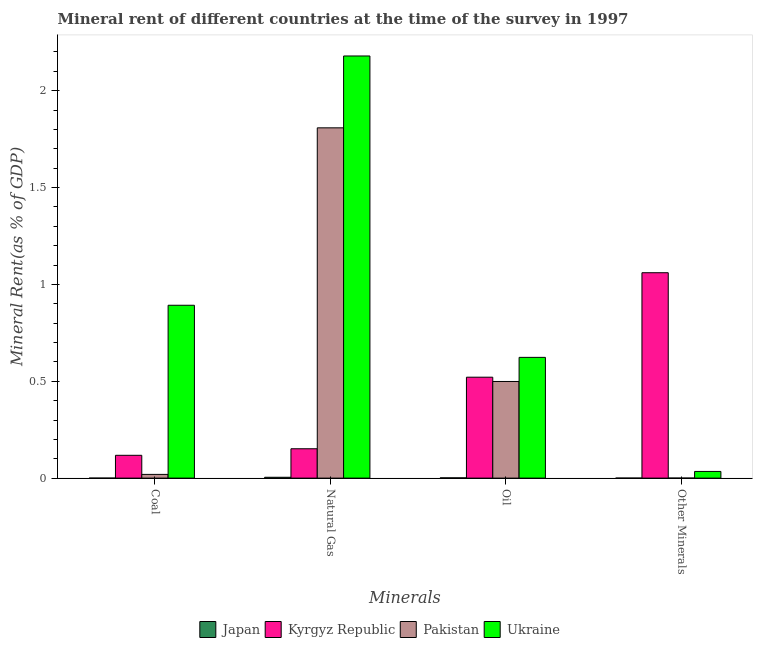Are the number of bars per tick equal to the number of legend labels?
Your response must be concise. Yes. Are the number of bars on each tick of the X-axis equal?
Provide a succinct answer. Yes. How many bars are there on the 3rd tick from the right?
Your answer should be compact. 4. What is the label of the 4th group of bars from the left?
Provide a short and direct response. Other Minerals. What is the natural gas rent in Pakistan?
Provide a succinct answer. 1.81. Across all countries, what is the maximum  rent of other minerals?
Provide a succinct answer. 1.06. Across all countries, what is the minimum oil rent?
Your answer should be compact. 0. In which country was the natural gas rent maximum?
Provide a succinct answer. Ukraine. In which country was the oil rent minimum?
Offer a terse response. Japan. What is the total  rent of other minerals in the graph?
Your answer should be compact. 1.1. What is the difference between the  rent of other minerals in Japan and that in Kyrgyz Republic?
Provide a short and direct response. -1.06. What is the difference between the  rent of other minerals in Japan and the coal rent in Ukraine?
Your answer should be compact. -0.89. What is the average  rent of other minerals per country?
Your answer should be very brief. 0.27. What is the difference between the oil rent and natural gas rent in Ukraine?
Ensure brevity in your answer.  -1.56. In how many countries, is the coal rent greater than 0.8 %?
Make the answer very short. 1. What is the ratio of the  rent of other minerals in Pakistan to that in Kyrgyz Republic?
Your answer should be compact. 0. Is the  rent of other minerals in Pakistan less than that in Kyrgyz Republic?
Ensure brevity in your answer.  Yes. What is the difference between the highest and the second highest oil rent?
Keep it short and to the point. 0.1. What is the difference between the highest and the lowest natural gas rent?
Offer a very short reply. 2.18. What does the 3rd bar from the left in Other Minerals represents?
Offer a terse response. Pakistan. What does the 3rd bar from the right in Coal represents?
Provide a succinct answer. Kyrgyz Republic. How many bars are there?
Provide a short and direct response. 16. Are all the bars in the graph horizontal?
Keep it short and to the point. No. How many countries are there in the graph?
Make the answer very short. 4. Are the values on the major ticks of Y-axis written in scientific E-notation?
Make the answer very short. No. How many legend labels are there?
Offer a very short reply. 4. What is the title of the graph?
Give a very brief answer. Mineral rent of different countries at the time of the survey in 1997. Does "Kenya" appear as one of the legend labels in the graph?
Keep it short and to the point. No. What is the label or title of the X-axis?
Offer a terse response. Minerals. What is the label or title of the Y-axis?
Keep it short and to the point. Mineral Rent(as % of GDP). What is the Mineral Rent(as % of GDP) of Japan in Coal?
Ensure brevity in your answer.  3.73329215235604e-7. What is the Mineral Rent(as % of GDP) in Kyrgyz Republic in Coal?
Keep it short and to the point. 0.12. What is the Mineral Rent(as % of GDP) in Pakistan in Coal?
Offer a terse response. 0.02. What is the Mineral Rent(as % of GDP) of Ukraine in Coal?
Offer a terse response. 0.89. What is the Mineral Rent(as % of GDP) in Japan in Natural Gas?
Provide a succinct answer. 0. What is the Mineral Rent(as % of GDP) in Kyrgyz Republic in Natural Gas?
Offer a terse response. 0.15. What is the Mineral Rent(as % of GDP) in Pakistan in Natural Gas?
Offer a very short reply. 1.81. What is the Mineral Rent(as % of GDP) of Ukraine in Natural Gas?
Your answer should be very brief. 2.18. What is the Mineral Rent(as % of GDP) in Japan in Oil?
Make the answer very short. 0. What is the Mineral Rent(as % of GDP) of Kyrgyz Republic in Oil?
Your answer should be very brief. 0.52. What is the Mineral Rent(as % of GDP) in Pakistan in Oil?
Give a very brief answer. 0.5. What is the Mineral Rent(as % of GDP) in Ukraine in Oil?
Give a very brief answer. 0.62. What is the Mineral Rent(as % of GDP) of Japan in Other Minerals?
Your answer should be compact. 4.86493891704915e-5. What is the Mineral Rent(as % of GDP) of Kyrgyz Republic in Other Minerals?
Your answer should be compact. 1.06. What is the Mineral Rent(as % of GDP) of Pakistan in Other Minerals?
Provide a short and direct response. 0. What is the Mineral Rent(as % of GDP) in Ukraine in Other Minerals?
Offer a terse response. 0.03. Across all Minerals, what is the maximum Mineral Rent(as % of GDP) in Japan?
Ensure brevity in your answer.  0. Across all Minerals, what is the maximum Mineral Rent(as % of GDP) of Kyrgyz Republic?
Provide a succinct answer. 1.06. Across all Minerals, what is the maximum Mineral Rent(as % of GDP) of Pakistan?
Offer a terse response. 1.81. Across all Minerals, what is the maximum Mineral Rent(as % of GDP) of Ukraine?
Your answer should be compact. 2.18. Across all Minerals, what is the minimum Mineral Rent(as % of GDP) in Japan?
Your answer should be very brief. 3.73329215235604e-7. Across all Minerals, what is the minimum Mineral Rent(as % of GDP) of Kyrgyz Republic?
Your answer should be compact. 0.12. Across all Minerals, what is the minimum Mineral Rent(as % of GDP) of Pakistan?
Offer a terse response. 0. Across all Minerals, what is the minimum Mineral Rent(as % of GDP) of Ukraine?
Give a very brief answer. 0.03. What is the total Mineral Rent(as % of GDP) of Japan in the graph?
Make the answer very short. 0.01. What is the total Mineral Rent(as % of GDP) in Kyrgyz Republic in the graph?
Give a very brief answer. 1.85. What is the total Mineral Rent(as % of GDP) of Pakistan in the graph?
Offer a terse response. 2.33. What is the total Mineral Rent(as % of GDP) of Ukraine in the graph?
Make the answer very short. 3.73. What is the difference between the Mineral Rent(as % of GDP) in Japan in Coal and that in Natural Gas?
Offer a terse response. -0. What is the difference between the Mineral Rent(as % of GDP) in Kyrgyz Republic in Coal and that in Natural Gas?
Make the answer very short. -0.03. What is the difference between the Mineral Rent(as % of GDP) in Pakistan in Coal and that in Natural Gas?
Offer a very short reply. -1.79. What is the difference between the Mineral Rent(as % of GDP) in Ukraine in Coal and that in Natural Gas?
Your answer should be compact. -1.29. What is the difference between the Mineral Rent(as % of GDP) of Japan in Coal and that in Oil?
Offer a terse response. -0. What is the difference between the Mineral Rent(as % of GDP) of Kyrgyz Republic in Coal and that in Oil?
Provide a succinct answer. -0.4. What is the difference between the Mineral Rent(as % of GDP) of Pakistan in Coal and that in Oil?
Keep it short and to the point. -0.48. What is the difference between the Mineral Rent(as % of GDP) of Ukraine in Coal and that in Oil?
Your answer should be very brief. 0.27. What is the difference between the Mineral Rent(as % of GDP) of Japan in Coal and that in Other Minerals?
Provide a succinct answer. -0. What is the difference between the Mineral Rent(as % of GDP) in Kyrgyz Republic in Coal and that in Other Minerals?
Make the answer very short. -0.94. What is the difference between the Mineral Rent(as % of GDP) in Pakistan in Coal and that in Other Minerals?
Make the answer very short. 0.02. What is the difference between the Mineral Rent(as % of GDP) in Ukraine in Coal and that in Other Minerals?
Your response must be concise. 0.86. What is the difference between the Mineral Rent(as % of GDP) of Japan in Natural Gas and that in Oil?
Your answer should be compact. 0. What is the difference between the Mineral Rent(as % of GDP) of Kyrgyz Republic in Natural Gas and that in Oil?
Provide a short and direct response. -0.37. What is the difference between the Mineral Rent(as % of GDP) in Pakistan in Natural Gas and that in Oil?
Provide a succinct answer. 1.31. What is the difference between the Mineral Rent(as % of GDP) in Ukraine in Natural Gas and that in Oil?
Provide a succinct answer. 1.56. What is the difference between the Mineral Rent(as % of GDP) in Japan in Natural Gas and that in Other Minerals?
Your response must be concise. 0. What is the difference between the Mineral Rent(as % of GDP) of Kyrgyz Republic in Natural Gas and that in Other Minerals?
Your answer should be compact. -0.91. What is the difference between the Mineral Rent(as % of GDP) in Pakistan in Natural Gas and that in Other Minerals?
Offer a very short reply. 1.81. What is the difference between the Mineral Rent(as % of GDP) of Ukraine in Natural Gas and that in Other Minerals?
Offer a terse response. 2.15. What is the difference between the Mineral Rent(as % of GDP) in Japan in Oil and that in Other Minerals?
Your answer should be very brief. 0. What is the difference between the Mineral Rent(as % of GDP) of Kyrgyz Republic in Oil and that in Other Minerals?
Give a very brief answer. -0.54. What is the difference between the Mineral Rent(as % of GDP) in Pakistan in Oil and that in Other Minerals?
Your answer should be very brief. 0.5. What is the difference between the Mineral Rent(as % of GDP) of Ukraine in Oil and that in Other Minerals?
Give a very brief answer. 0.59. What is the difference between the Mineral Rent(as % of GDP) in Japan in Coal and the Mineral Rent(as % of GDP) in Kyrgyz Republic in Natural Gas?
Offer a very short reply. -0.15. What is the difference between the Mineral Rent(as % of GDP) in Japan in Coal and the Mineral Rent(as % of GDP) in Pakistan in Natural Gas?
Give a very brief answer. -1.81. What is the difference between the Mineral Rent(as % of GDP) in Japan in Coal and the Mineral Rent(as % of GDP) in Ukraine in Natural Gas?
Your answer should be very brief. -2.18. What is the difference between the Mineral Rent(as % of GDP) of Kyrgyz Republic in Coal and the Mineral Rent(as % of GDP) of Pakistan in Natural Gas?
Give a very brief answer. -1.69. What is the difference between the Mineral Rent(as % of GDP) in Kyrgyz Republic in Coal and the Mineral Rent(as % of GDP) in Ukraine in Natural Gas?
Provide a succinct answer. -2.06. What is the difference between the Mineral Rent(as % of GDP) of Pakistan in Coal and the Mineral Rent(as % of GDP) of Ukraine in Natural Gas?
Your answer should be compact. -2.16. What is the difference between the Mineral Rent(as % of GDP) in Japan in Coal and the Mineral Rent(as % of GDP) in Kyrgyz Republic in Oil?
Ensure brevity in your answer.  -0.52. What is the difference between the Mineral Rent(as % of GDP) of Japan in Coal and the Mineral Rent(as % of GDP) of Pakistan in Oil?
Your response must be concise. -0.5. What is the difference between the Mineral Rent(as % of GDP) in Japan in Coal and the Mineral Rent(as % of GDP) in Ukraine in Oil?
Give a very brief answer. -0.62. What is the difference between the Mineral Rent(as % of GDP) of Kyrgyz Republic in Coal and the Mineral Rent(as % of GDP) of Pakistan in Oil?
Your answer should be very brief. -0.38. What is the difference between the Mineral Rent(as % of GDP) of Kyrgyz Republic in Coal and the Mineral Rent(as % of GDP) of Ukraine in Oil?
Offer a very short reply. -0.51. What is the difference between the Mineral Rent(as % of GDP) in Pakistan in Coal and the Mineral Rent(as % of GDP) in Ukraine in Oil?
Give a very brief answer. -0.6. What is the difference between the Mineral Rent(as % of GDP) of Japan in Coal and the Mineral Rent(as % of GDP) of Kyrgyz Republic in Other Minerals?
Offer a very short reply. -1.06. What is the difference between the Mineral Rent(as % of GDP) in Japan in Coal and the Mineral Rent(as % of GDP) in Pakistan in Other Minerals?
Your answer should be very brief. -0. What is the difference between the Mineral Rent(as % of GDP) in Japan in Coal and the Mineral Rent(as % of GDP) in Ukraine in Other Minerals?
Your response must be concise. -0.03. What is the difference between the Mineral Rent(as % of GDP) in Kyrgyz Republic in Coal and the Mineral Rent(as % of GDP) in Pakistan in Other Minerals?
Ensure brevity in your answer.  0.12. What is the difference between the Mineral Rent(as % of GDP) in Kyrgyz Republic in Coal and the Mineral Rent(as % of GDP) in Ukraine in Other Minerals?
Provide a short and direct response. 0.08. What is the difference between the Mineral Rent(as % of GDP) of Pakistan in Coal and the Mineral Rent(as % of GDP) of Ukraine in Other Minerals?
Your answer should be very brief. -0.02. What is the difference between the Mineral Rent(as % of GDP) of Japan in Natural Gas and the Mineral Rent(as % of GDP) of Kyrgyz Republic in Oil?
Your response must be concise. -0.52. What is the difference between the Mineral Rent(as % of GDP) in Japan in Natural Gas and the Mineral Rent(as % of GDP) in Pakistan in Oil?
Offer a terse response. -0.49. What is the difference between the Mineral Rent(as % of GDP) of Japan in Natural Gas and the Mineral Rent(as % of GDP) of Ukraine in Oil?
Keep it short and to the point. -0.62. What is the difference between the Mineral Rent(as % of GDP) in Kyrgyz Republic in Natural Gas and the Mineral Rent(as % of GDP) in Pakistan in Oil?
Give a very brief answer. -0.35. What is the difference between the Mineral Rent(as % of GDP) in Kyrgyz Republic in Natural Gas and the Mineral Rent(as % of GDP) in Ukraine in Oil?
Provide a succinct answer. -0.47. What is the difference between the Mineral Rent(as % of GDP) of Pakistan in Natural Gas and the Mineral Rent(as % of GDP) of Ukraine in Oil?
Your answer should be very brief. 1.19. What is the difference between the Mineral Rent(as % of GDP) of Japan in Natural Gas and the Mineral Rent(as % of GDP) of Kyrgyz Republic in Other Minerals?
Provide a succinct answer. -1.06. What is the difference between the Mineral Rent(as % of GDP) of Japan in Natural Gas and the Mineral Rent(as % of GDP) of Pakistan in Other Minerals?
Your answer should be very brief. 0. What is the difference between the Mineral Rent(as % of GDP) in Japan in Natural Gas and the Mineral Rent(as % of GDP) in Ukraine in Other Minerals?
Your response must be concise. -0.03. What is the difference between the Mineral Rent(as % of GDP) in Kyrgyz Republic in Natural Gas and the Mineral Rent(as % of GDP) in Pakistan in Other Minerals?
Ensure brevity in your answer.  0.15. What is the difference between the Mineral Rent(as % of GDP) in Kyrgyz Republic in Natural Gas and the Mineral Rent(as % of GDP) in Ukraine in Other Minerals?
Keep it short and to the point. 0.12. What is the difference between the Mineral Rent(as % of GDP) of Pakistan in Natural Gas and the Mineral Rent(as % of GDP) of Ukraine in Other Minerals?
Provide a succinct answer. 1.77. What is the difference between the Mineral Rent(as % of GDP) of Japan in Oil and the Mineral Rent(as % of GDP) of Kyrgyz Republic in Other Minerals?
Your answer should be very brief. -1.06. What is the difference between the Mineral Rent(as % of GDP) in Japan in Oil and the Mineral Rent(as % of GDP) in Pakistan in Other Minerals?
Your response must be concise. 0. What is the difference between the Mineral Rent(as % of GDP) in Japan in Oil and the Mineral Rent(as % of GDP) in Ukraine in Other Minerals?
Make the answer very short. -0.03. What is the difference between the Mineral Rent(as % of GDP) in Kyrgyz Republic in Oil and the Mineral Rent(as % of GDP) in Pakistan in Other Minerals?
Your answer should be compact. 0.52. What is the difference between the Mineral Rent(as % of GDP) of Kyrgyz Republic in Oil and the Mineral Rent(as % of GDP) of Ukraine in Other Minerals?
Keep it short and to the point. 0.49. What is the difference between the Mineral Rent(as % of GDP) in Pakistan in Oil and the Mineral Rent(as % of GDP) in Ukraine in Other Minerals?
Make the answer very short. 0.46. What is the average Mineral Rent(as % of GDP) in Japan per Minerals?
Your answer should be compact. 0. What is the average Mineral Rent(as % of GDP) of Kyrgyz Republic per Minerals?
Your answer should be compact. 0.46. What is the average Mineral Rent(as % of GDP) in Pakistan per Minerals?
Offer a very short reply. 0.58. What is the average Mineral Rent(as % of GDP) in Ukraine per Minerals?
Your response must be concise. 0.93. What is the difference between the Mineral Rent(as % of GDP) in Japan and Mineral Rent(as % of GDP) in Kyrgyz Republic in Coal?
Provide a succinct answer. -0.12. What is the difference between the Mineral Rent(as % of GDP) in Japan and Mineral Rent(as % of GDP) in Pakistan in Coal?
Your response must be concise. -0.02. What is the difference between the Mineral Rent(as % of GDP) of Japan and Mineral Rent(as % of GDP) of Ukraine in Coal?
Give a very brief answer. -0.89. What is the difference between the Mineral Rent(as % of GDP) of Kyrgyz Republic and Mineral Rent(as % of GDP) of Pakistan in Coal?
Offer a terse response. 0.1. What is the difference between the Mineral Rent(as % of GDP) in Kyrgyz Republic and Mineral Rent(as % of GDP) in Ukraine in Coal?
Your response must be concise. -0.77. What is the difference between the Mineral Rent(as % of GDP) in Pakistan and Mineral Rent(as % of GDP) in Ukraine in Coal?
Your response must be concise. -0.87. What is the difference between the Mineral Rent(as % of GDP) of Japan and Mineral Rent(as % of GDP) of Kyrgyz Republic in Natural Gas?
Give a very brief answer. -0.15. What is the difference between the Mineral Rent(as % of GDP) in Japan and Mineral Rent(as % of GDP) in Pakistan in Natural Gas?
Provide a succinct answer. -1.8. What is the difference between the Mineral Rent(as % of GDP) in Japan and Mineral Rent(as % of GDP) in Ukraine in Natural Gas?
Offer a very short reply. -2.17. What is the difference between the Mineral Rent(as % of GDP) in Kyrgyz Republic and Mineral Rent(as % of GDP) in Pakistan in Natural Gas?
Offer a very short reply. -1.66. What is the difference between the Mineral Rent(as % of GDP) in Kyrgyz Republic and Mineral Rent(as % of GDP) in Ukraine in Natural Gas?
Provide a succinct answer. -2.03. What is the difference between the Mineral Rent(as % of GDP) in Pakistan and Mineral Rent(as % of GDP) in Ukraine in Natural Gas?
Keep it short and to the point. -0.37. What is the difference between the Mineral Rent(as % of GDP) of Japan and Mineral Rent(as % of GDP) of Kyrgyz Republic in Oil?
Offer a terse response. -0.52. What is the difference between the Mineral Rent(as % of GDP) in Japan and Mineral Rent(as % of GDP) in Pakistan in Oil?
Provide a succinct answer. -0.5. What is the difference between the Mineral Rent(as % of GDP) in Japan and Mineral Rent(as % of GDP) in Ukraine in Oil?
Keep it short and to the point. -0.62. What is the difference between the Mineral Rent(as % of GDP) of Kyrgyz Republic and Mineral Rent(as % of GDP) of Pakistan in Oil?
Your answer should be very brief. 0.02. What is the difference between the Mineral Rent(as % of GDP) of Kyrgyz Republic and Mineral Rent(as % of GDP) of Ukraine in Oil?
Ensure brevity in your answer.  -0.1. What is the difference between the Mineral Rent(as % of GDP) of Pakistan and Mineral Rent(as % of GDP) of Ukraine in Oil?
Provide a succinct answer. -0.12. What is the difference between the Mineral Rent(as % of GDP) of Japan and Mineral Rent(as % of GDP) of Kyrgyz Republic in Other Minerals?
Provide a succinct answer. -1.06. What is the difference between the Mineral Rent(as % of GDP) in Japan and Mineral Rent(as % of GDP) in Pakistan in Other Minerals?
Provide a succinct answer. -0. What is the difference between the Mineral Rent(as % of GDP) of Japan and Mineral Rent(as % of GDP) of Ukraine in Other Minerals?
Give a very brief answer. -0.03. What is the difference between the Mineral Rent(as % of GDP) in Kyrgyz Republic and Mineral Rent(as % of GDP) in Pakistan in Other Minerals?
Ensure brevity in your answer.  1.06. What is the difference between the Mineral Rent(as % of GDP) of Kyrgyz Republic and Mineral Rent(as % of GDP) of Ukraine in Other Minerals?
Offer a very short reply. 1.03. What is the difference between the Mineral Rent(as % of GDP) of Pakistan and Mineral Rent(as % of GDP) of Ukraine in Other Minerals?
Offer a very short reply. -0.03. What is the ratio of the Mineral Rent(as % of GDP) in Kyrgyz Republic in Coal to that in Natural Gas?
Provide a short and direct response. 0.78. What is the ratio of the Mineral Rent(as % of GDP) of Pakistan in Coal to that in Natural Gas?
Your answer should be compact. 0.01. What is the ratio of the Mineral Rent(as % of GDP) in Ukraine in Coal to that in Natural Gas?
Make the answer very short. 0.41. What is the ratio of the Mineral Rent(as % of GDP) in Kyrgyz Republic in Coal to that in Oil?
Provide a succinct answer. 0.23. What is the ratio of the Mineral Rent(as % of GDP) of Pakistan in Coal to that in Oil?
Give a very brief answer. 0.04. What is the ratio of the Mineral Rent(as % of GDP) of Ukraine in Coal to that in Oil?
Keep it short and to the point. 1.43. What is the ratio of the Mineral Rent(as % of GDP) in Japan in Coal to that in Other Minerals?
Keep it short and to the point. 0.01. What is the ratio of the Mineral Rent(as % of GDP) of Pakistan in Coal to that in Other Minerals?
Keep it short and to the point. 161.49. What is the ratio of the Mineral Rent(as % of GDP) in Ukraine in Coal to that in Other Minerals?
Your response must be concise. 25.9. What is the ratio of the Mineral Rent(as % of GDP) in Japan in Natural Gas to that in Oil?
Provide a short and direct response. 3.28. What is the ratio of the Mineral Rent(as % of GDP) of Kyrgyz Republic in Natural Gas to that in Oil?
Your response must be concise. 0.29. What is the ratio of the Mineral Rent(as % of GDP) in Pakistan in Natural Gas to that in Oil?
Provide a short and direct response. 3.62. What is the ratio of the Mineral Rent(as % of GDP) in Ukraine in Natural Gas to that in Oil?
Your response must be concise. 3.5. What is the ratio of the Mineral Rent(as % of GDP) of Japan in Natural Gas to that in Other Minerals?
Your answer should be compact. 90.22. What is the ratio of the Mineral Rent(as % of GDP) of Kyrgyz Republic in Natural Gas to that in Other Minerals?
Provide a short and direct response. 0.14. What is the ratio of the Mineral Rent(as % of GDP) in Pakistan in Natural Gas to that in Other Minerals?
Your answer should be very brief. 1.52e+04. What is the ratio of the Mineral Rent(as % of GDP) of Ukraine in Natural Gas to that in Other Minerals?
Provide a succinct answer. 63.25. What is the ratio of the Mineral Rent(as % of GDP) in Japan in Oil to that in Other Minerals?
Your answer should be very brief. 27.53. What is the ratio of the Mineral Rent(as % of GDP) of Kyrgyz Republic in Oil to that in Other Minerals?
Your answer should be compact. 0.49. What is the ratio of the Mineral Rent(as % of GDP) of Pakistan in Oil to that in Other Minerals?
Ensure brevity in your answer.  4193.26. What is the ratio of the Mineral Rent(as % of GDP) of Ukraine in Oil to that in Other Minerals?
Your response must be concise. 18.09. What is the difference between the highest and the second highest Mineral Rent(as % of GDP) of Japan?
Offer a terse response. 0. What is the difference between the highest and the second highest Mineral Rent(as % of GDP) in Kyrgyz Republic?
Keep it short and to the point. 0.54. What is the difference between the highest and the second highest Mineral Rent(as % of GDP) in Pakistan?
Make the answer very short. 1.31. What is the difference between the highest and the second highest Mineral Rent(as % of GDP) in Ukraine?
Offer a terse response. 1.29. What is the difference between the highest and the lowest Mineral Rent(as % of GDP) in Japan?
Offer a very short reply. 0. What is the difference between the highest and the lowest Mineral Rent(as % of GDP) in Kyrgyz Republic?
Provide a succinct answer. 0.94. What is the difference between the highest and the lowest Mineral Rent(as % of GDP) in Pakistan?
Your answer should be very brief. 1.81. What is the difference between the highest and the lowest Mineral Rent(as % of GDP) in Ukraine?
Your answer should be compact. 2.15. 